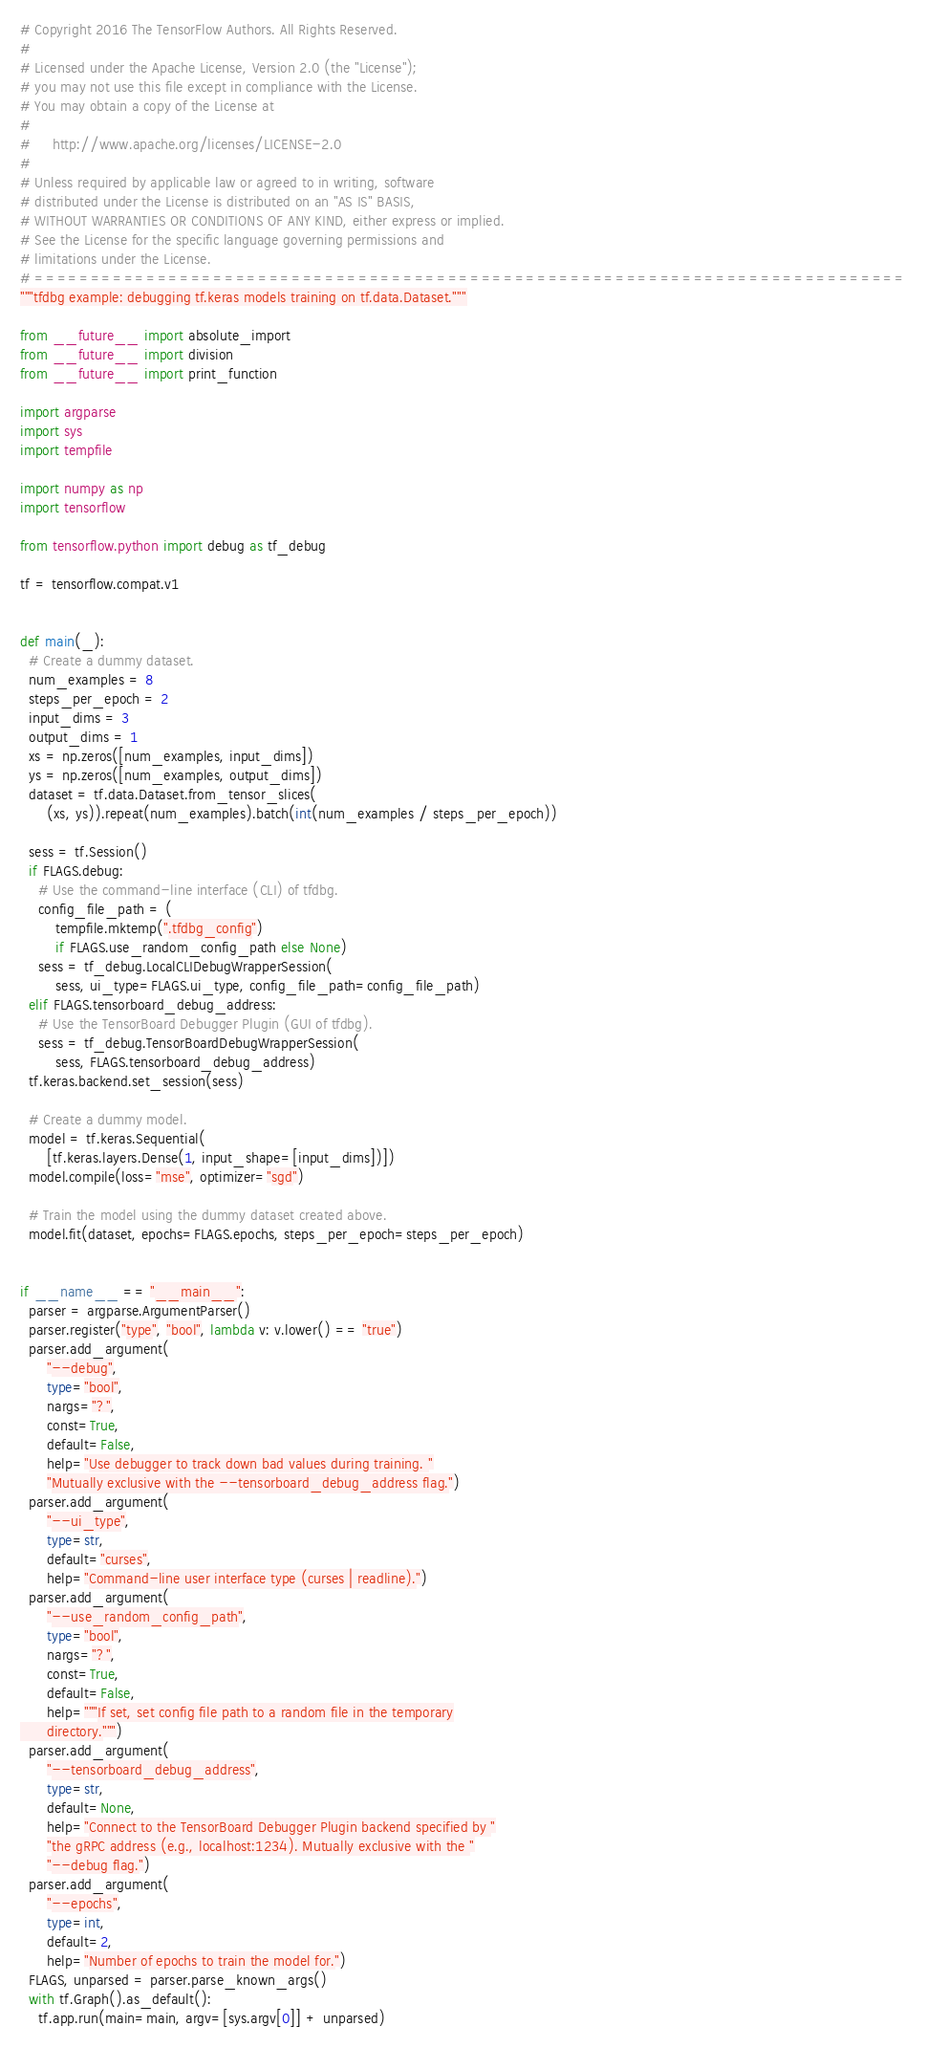Convert code to text. <code><loc_0><loc_0><loc_500><loc_500><_Python_># Copyright 2016 The TensorFlow Authors. All Rights Reserved.
#
# Licensed under the Apache License, Version 2.0 (the "License");
# you may not use this file except in compliance with the License.
# You may obtain a copy of the License at
#
#     http://www.apache.org/licenses/LICENSE-2.0
#
# Unless required by applicable law or agreed to in writing, software
# distributed under the License is distributed on an "AS IS" BASIS,
# WITHOUT WARRANTIES OR CONDITIONS OF ANY KIND, either express or implied.
# See the License for the specific language governing permissions and
# limitations under the License.
# ==============================================================================
"""tfdbg example: debugging tf.keras models training on tf.data.Dataset."""

from __future__ import absolute_import
from __future__ import division
from __future__ import print_function

import argparse
import sys
import tempfile

import numpy as np
import tensorflow

from tensorflow.python import debug as tf_debug

tf = tensorflow.compat.v1


def main(_):
  # Create a dummy dataset.
  num_examples = 8
  steps_per_epoch = 2
  input_dims = 3
  output_dims = 1
  xs = np.zeros([num_examples, input_dims])
  ys = np.zeros([num_examples, output_dims])
  dataset = tf.data.Dataset.from_tensor_slices(
      (xs, ys)).repeat(num_examples).batch(int(num_examples / steps_per_epoch))

  sess = tf.Session()
  if FLAGS.debug:
    # Use the command-line interface (CLI) of tfdbg.
    config_file_path = (
        tempfile.mktemp(".tfdbg_config")
        if FLAGS.use_random_config_path else None)
    sess = tf_debug.LocalCLIDebugWrapperSession(
        sess, ui_type=FLAGS.ui_type, config_file_path=config_file_path)
  elif FLAGS.tensorboard_debug_address:
    # Use the TensorBoard Debugger Plugin (GUI of tfdbg).
    sess = tf_debug.TensorBoardDebugWrapperSession(
        sess, FLAGS.tensorboard_debug_address)
  tf.keras.backend.set_session(sess)

  # Create a dummy model.
  model = tf.keras.Sequential(
      [tf.keras.layers.Dense(1, input_shape=[input_dims])])
  model.compile(loss="mse", optimizer="sgd")

  # Train the model using the dummy dataset created above.
  model.fit(dataset, epochs=FLAGS.epochs, steps_per_epoch=steps_per_epoch)


if __name__ == "__main__":
  parser = argparse.ArgumentParser()
  parser.register("type", "bool", lambda v: v.lower() == "true")
  parser.add_argument(
      "--debug",
      type="bool",
      nargs="?",
      const=True,
      default=False,
      help="Use debugger to track down bad values during training. "
      "Mutually exclusive with the --tensorboard_debug_address flag.")
  parser.add_argument(
      "--ui_type",
      type=str,
      default="curses",
      help="Command-line user interface type (curses | readline).")
  parser.add_argument(
      "--use_random_config_path",
      type="bool",
      nargs="?",
      const=True,
      default=False,
      help="""If set, set config file path to a random file in the temporary
      directory.""")
  parser.add_argument(
      "--tensorboard_debug_address",
      type=str,
      default=None,
      help="Connect to the TensorBoard Debugger Plugin backend specified by "
      "the gRPC address (e.g., localhost:1234). Mutually exclusive with the "
      "--debug flag.")
  parser.add_argument(
      "--epochs",
      type=int,
      default=2,
      help="Number of epochs to train the model for.")
  FLAGS, unparsed = parser.parse_known_args()
  with tf.Graph().as_default():
    tf.app.run(main=main, argv=[sys.argv[0]] + unparsed)
</code> 